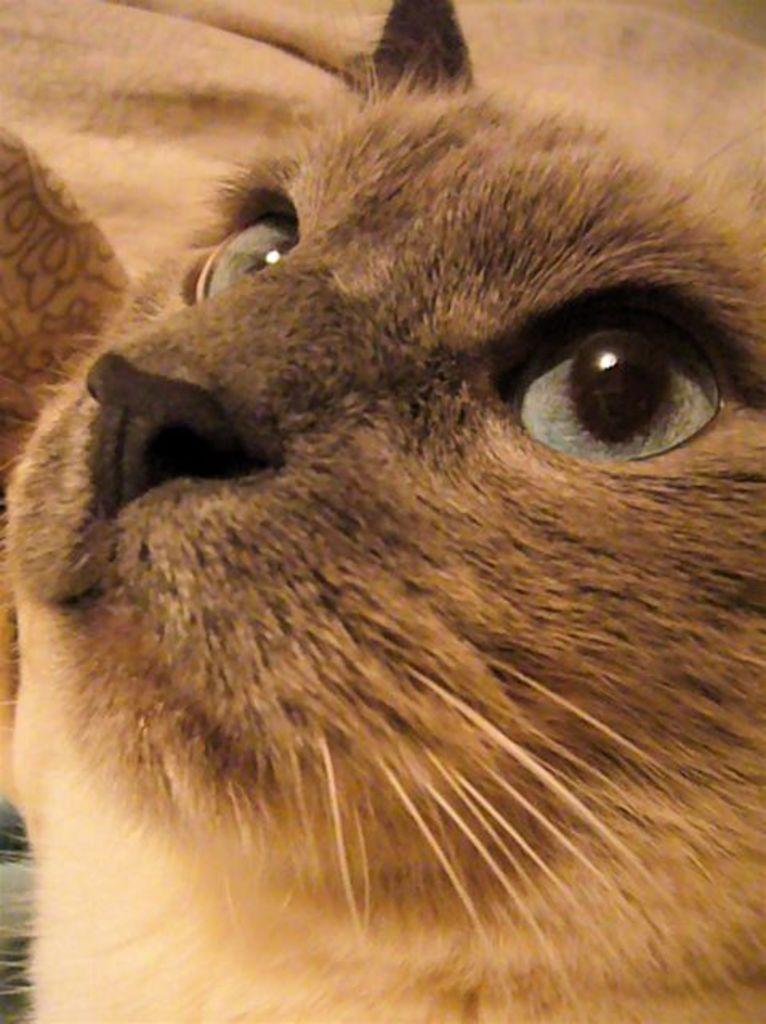What type of animal is in the image? There is a cat in the image. What can be seen in the background of the image? Cloth is visible in the background of the image. What is the condition of the cat's health in the image? The image does not provide any information about the cat's health, so it cannot be determined from the image. 